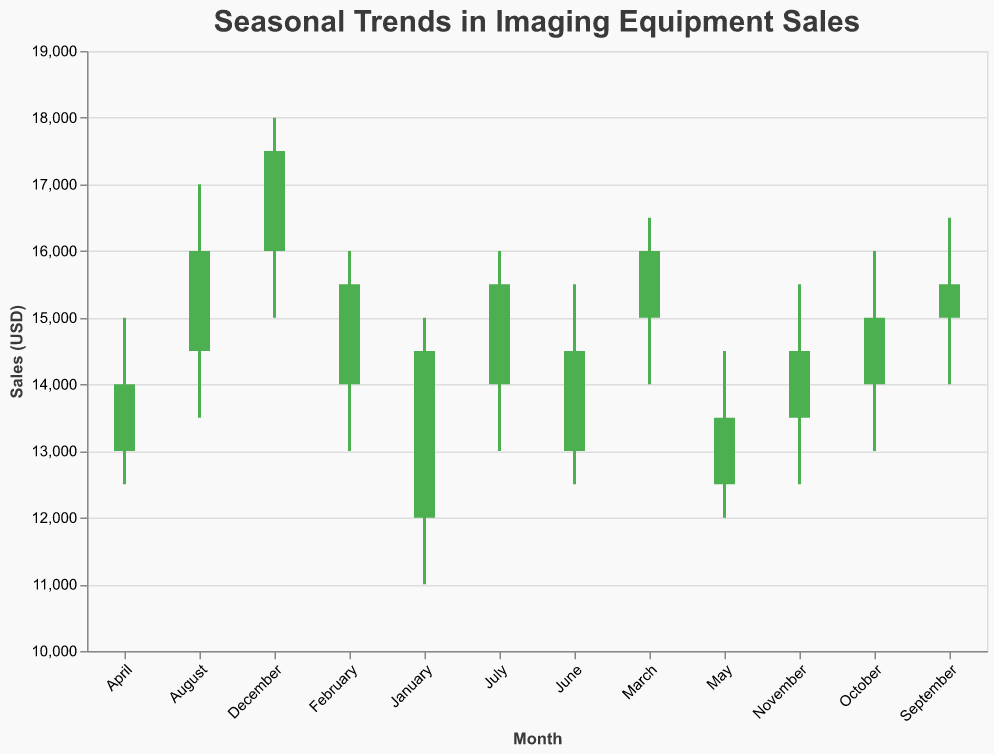What is the title of the figure? The title of a figure is typically found at the top and provides a summary of what the figure represents. The title helps set the context for interpreting the data. The title here is: "Seasonal Trends in Imaging Equipment Sales".
Answer: Seasonal Trends in Imaging Equipment Sales What is the range of sales values represented on the y-axis? The y-axis of the figure shows the scale of sales values, with the axis running from the minimum value at the bottom to the maximum value at the top. In this figure, the y-axis ranges from 10,000 to 19,000 USD.
Answer: 10,000 to 19,000 USD How does the sales trend change from January to December in general terms? To identify the general trend from January to December, look at the starting and ending sales points. Sales start at 14,500 in January and end at 17,500 in December. Overall, there is an upward trend in sales.
Answer: Upward trend In which month(s) did the sales see the highest maximum value, and what was this value? The highest maximum value is represented by the top of the candlestick, which is the "High" value for each month. Here, December has the highest value of 18,000.
Answer: December, 18,000 USD In how many months did the "Close" value exceed the "Open" value? The months where the "Close" value exceeds the "Open" value can be determined by observing the color of the candlesticks. Green-colored candlesticks indicate that the "Close" is higher than the "Open". There are 9 such months: January, February, March, June, July, August, September, November, December.
Answer: 9 months Which month experienced the greatest variability in sales and what is the range? Variability can be identified by the difference between the "High" and "Low" values. December has the greatest variability with a range of 18,000 - 15,000 = 3,000 USD.
Answer: December, 3,000 USD What is the average "Close" value for the months of February, March, and April? To find the average "Close" value, sum the "Close" values for February (15,500), March (16,000), and April (14,000) and then divide by 3. The calculation is (15,500 + 16,000 + 14,000) / 3 = 15,167 USD.
Answer: 15,167 USD Compare the sales performance in June and July. Which month had higher closing sales and by how much? To compare the closing sales, subtract the "Close" value of June from that of July. June's "Close" is 14,500 and July's "Close" is 15,500. The difference is 15,500 - 14,500 = 1,000 USD.
Answer: July, 1,000 USD Which month had the least difference between the "High" and "Low" values? The smallest difference between "High" and "Low" values indicates low variability. May had the least difference with values 14,500 - 12,000 = 2,500 USD.
Answer: May, 2,500 USD 